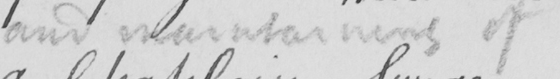Can you read and transcribe this handwriting? and maintaing of 